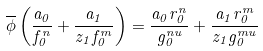<formula> <loc_0><loc_0><loc_500><loc_500>\overline { \phi } \left ( \frac { a _ { 0 } } { f _ { 0 } ^ { n } } + \frac { a _ { 1 } } { z _ { 1 } f _ { 0 } ^ { m } } \right ) = \frac { a _ { 0 } r _ { 0 } ^ { n } } { g _ { 0 } ^ { n u } } + \frac { a _ { 1 } r _ { 0 } ^ { m } } { z _ { 1 } g _ { 0 } ^ { m u } }</formula> 